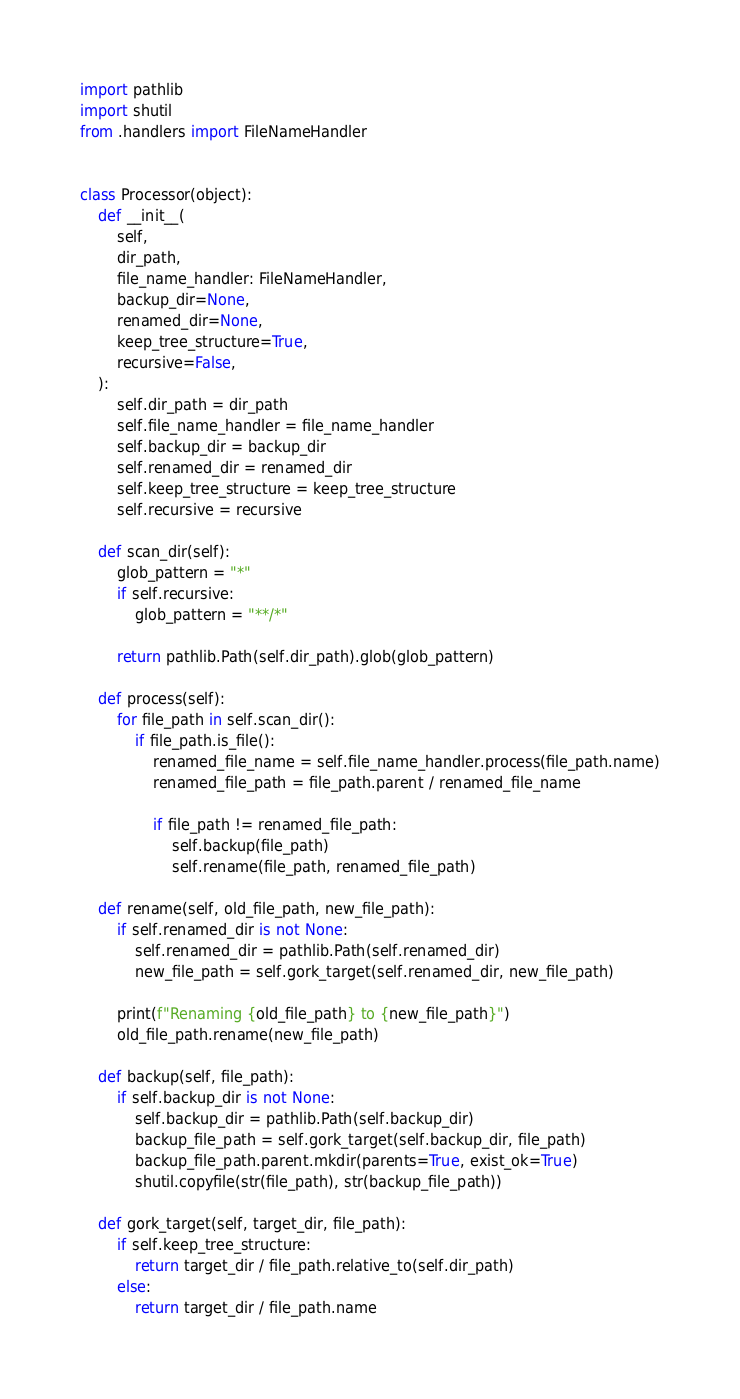<code> <loc_0><loc_0><loc_500><loc_500><_Python_>import pathlib
import shutil
from .handlers import FileNameHandler


class Processor(object):
    def __init__(
        self,
        dir_path,
        file_name_handler: FileNameHandler,
        backup_dir=None,
        renamed_dir=None,
        keep_tree_structure=True,
        recursive=False,
    ):
        self.dir_path = dir_path
        self.file_name_handler = file_name_handler
        self.backup_dir = backup_dir
        self.renamed_dir = renamed_dir
        self.keep_tree_structure = keep_tree_structure
        self.recursive = recursive

    def scan_dir(self):
        glob_pattern = "*"
        if self.recursive:
            glob_pattern = "**/*"

        return pathlib.Path(self.dir_path).glob(glob_pattern)

    def process(self):
        for file_path in self.scan_dir():
            if file_path.is_file():
                renamed_file_name = self.file_name_handler.process(file_path.name)
                renamed_file_path = file_path.parent / renamed_file_name

                if file_path != renamed_file_path:
                    self.backup(file_path)
                    self.rename(file_path, renamed_file_path)

    def rename(self, old_file_path, new_file_path):
        if self.renamed_dir is not None:
            self.renamed_dir = pathlib.Path(self.renamed_dir)
            new_file_path = self.gork_target(self.renamed_dir, new_file_path)

        print(f"Renaming {old_file_path} to {new_file_path}")
        old_file_path.rename(new_file_path)

    def backup(self, file_path):
        if self.backup_dir is not None:
            self.backup_dir = pathlib.Path(self.backup_dir)
            backup_file_path = self.gork_target(self.backup_dir, file_path)
            backup_file_path.parent.mkdir(parents=True, exist_ok=True)
            shutil.copyfile(str(file_path), str(backup_file_path))

    def gork_target(self, target_dir, file_path):
        if self.keep_tree_structure:
            return target_dir / file_path.relative_to(self.dir_path)
        else:
            return target_dir / file_path.name
</code> 